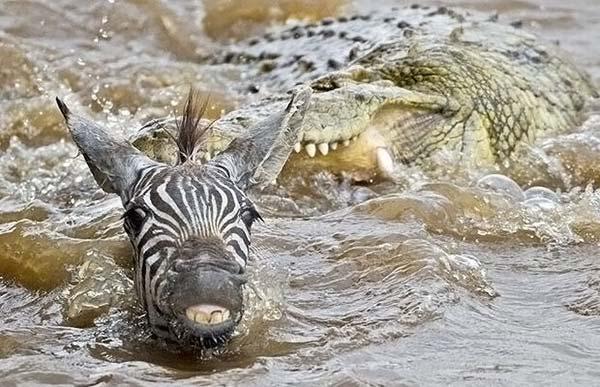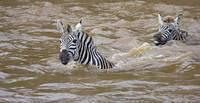The first image is the image on the left, the second image is the image on the right. Considering the images on both sides, is "The right image shows exactly two zebra heading leftward in neck-deep water, one behind the other, and the left image features a zebra with a different type of animal in the water." valid? Answer yes or no. Yes. The first image is the image on the left, the second image is the image on the right. For the images displayed, is the sentence "There are exactly three zebras." factually correct? Answer yes or no. Yes. 